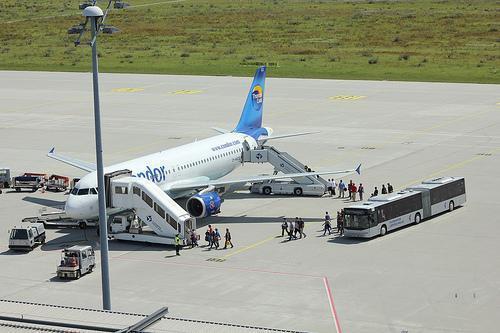How many planes are there?
Give a very brief answer. 1. 